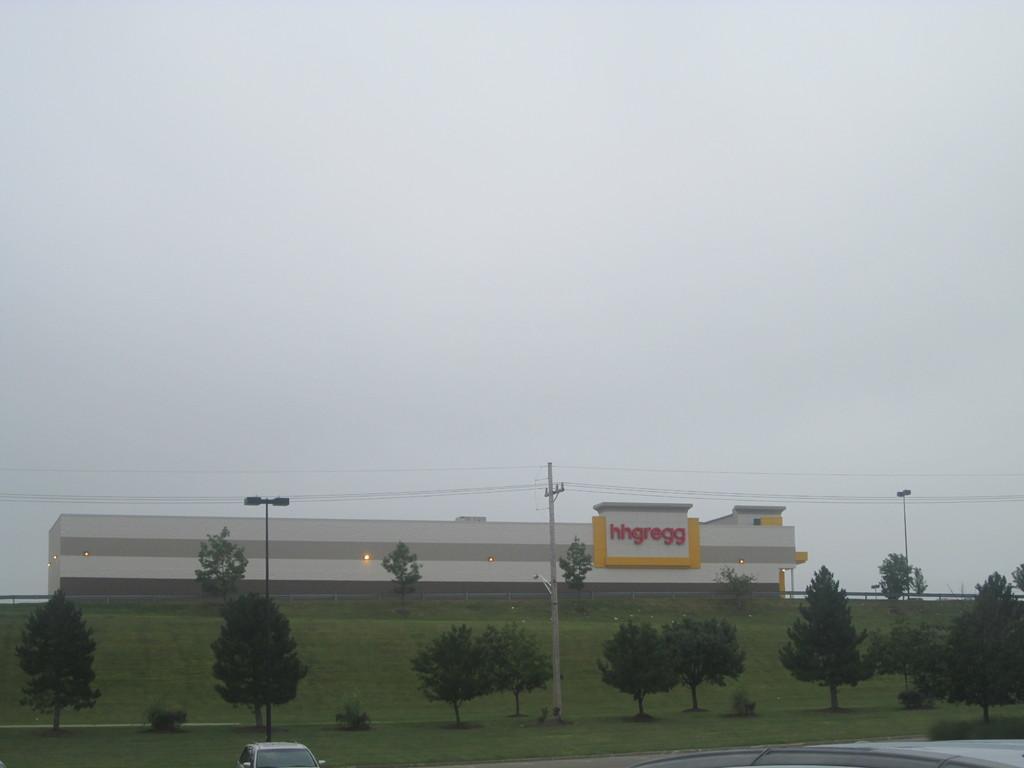How would you summarize this image in a sentence or two? In this picture I can see vehicles, plants, trees, poles, lights, a building, and in the background there is sky. 